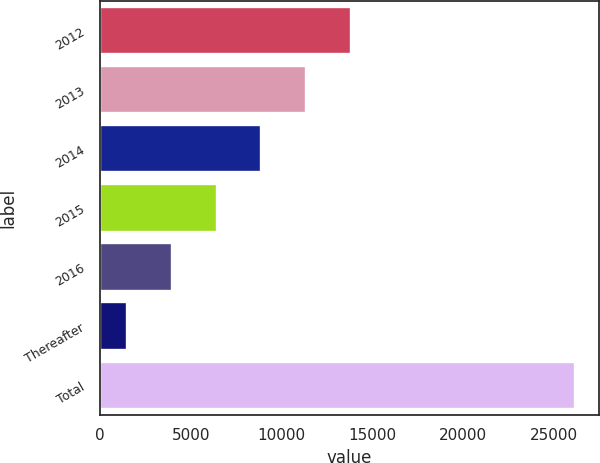Convert chart to OTSL. <chart><loc_0><loc_0><loc_500><loc_500><bar_chart><fcel>2012<fcel>2013<fcel>2014<fcel>2015<fcel>2016<fcel>Thereafter<fcel>Total<nl><fcel>13837<fcel>11367<fcel>8897<fcel>6427<fcel>3957<fcel>1487<fcel>26187<nl></chart> 